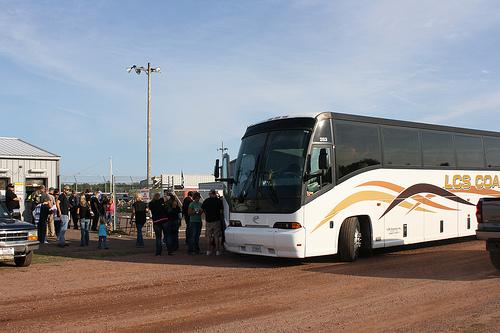Question: how are the people?
Choices:
A. Chatting.
B. Sleeping.
C. Standing.
D. Eating.
Answer with the letter. Answer: C Question: who is there?
Choices:
A. Security officers.
B. Bus driver.
C. Bus travelers.
D. Family.
Answer with the letter. Answer: C Question: when during the day is it?
Choices:
A. Morning.
B. Afternoon.
C. Night.
D. Bedtime.
Answer with the letter. Answer: B Question: where is this scene?
Choices:
A. On the street.
B. A hill side.
C. A back yard.
D. A busy city.
Answer with the letter. Answer: A 